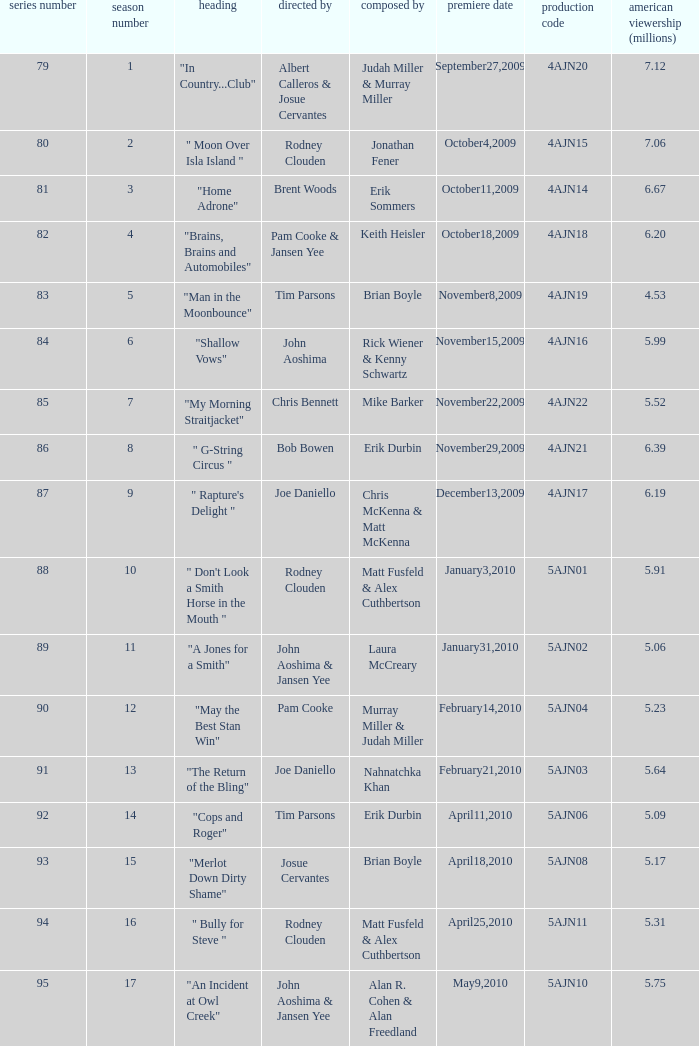Name the original air date for " don't look a smith horse in the mouth " January3,2010. 